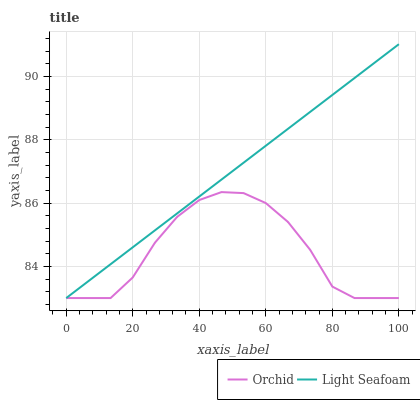Does Orchid have the minimum area under the curve?
Answer yes or no. Yes. Does Light Seafoam have the maximum area under the curve?
Answer yes or no. Yes. Does Orchid have the maximum area under the curve?
Answer yes or no. No. Is Light Seafoam the smoothest?
Answer yes or no. Yes. Is Orchid the roughest?
Answer yes or no. Yes. Is Orchid the smoothest?
Answer yes or no. No. Does Light Seafoam have the lowest value?
Answer yes or no. Yes. Does Light Seafoam have the highest value?
Answer yes or no. Yes. Does Orchid have the highest value?
Answer yes or no. No. Does Orchid intersect Light Seafoam?
Answer yes or no. Yes. Is Orchid less than Light Seafoam?
Answer yes or no. No. Is Orchid greater than Light Seafoam?
Answer yes or no. No. 